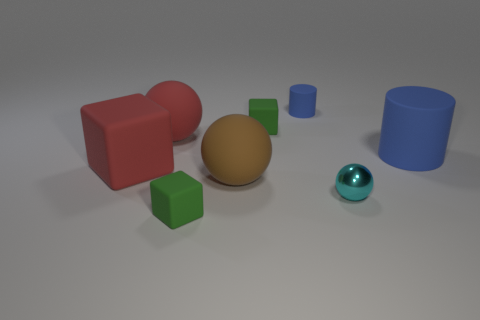Subtract all red matte spheres. How many spheres are left? 2 Add 1 small gray balls. How many objects exist? 9 Subtract all red cubes. How many cubes are left? 2 Subtract all balls. How many objects are left? 5 Subtract all green cylinders. How many cyan spheres are left? 1 Subtract all green matte objects. Subtract all rubber blocks. How many objects are left? 3 Add 8 large red objects. How many large red objects are left? 10 Add 2 purple rubber cubes. How many purple rubber cubes exist? 2 Subtract 0 brown cylinders. How many objects are left? 8 Subtract 1 spheres. How many spheres are left? 2 